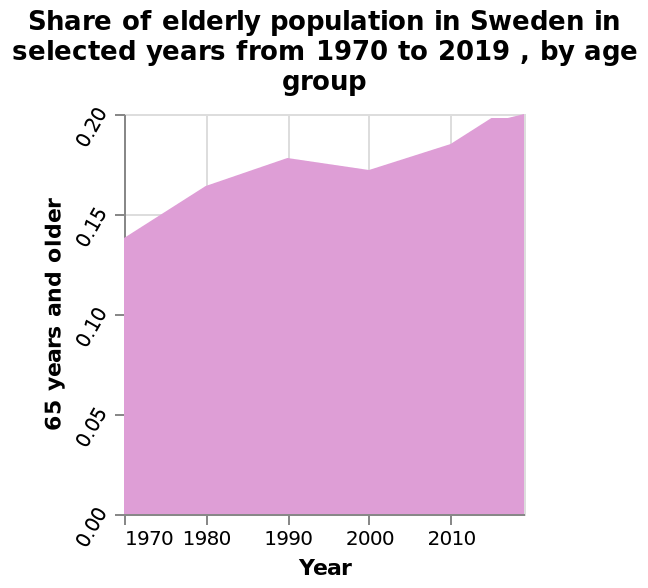<image>
Is there a specific explanation provided for the figures on the y-axis?  No, there is no specific explanation provided for the figures on the y-axis. In which year does the data collection for the selected years start? The data collection for the selected years starts in 1970. 